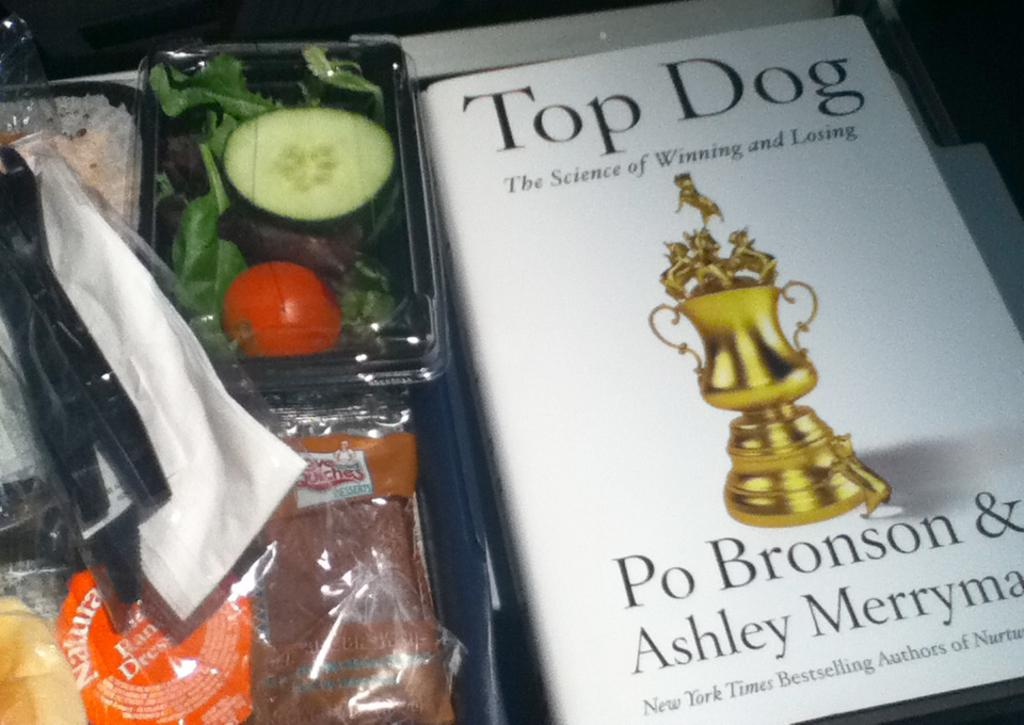<image>
Write a terse but informative summary of the picture. Book named Top Dog showing a trophy on the front. 